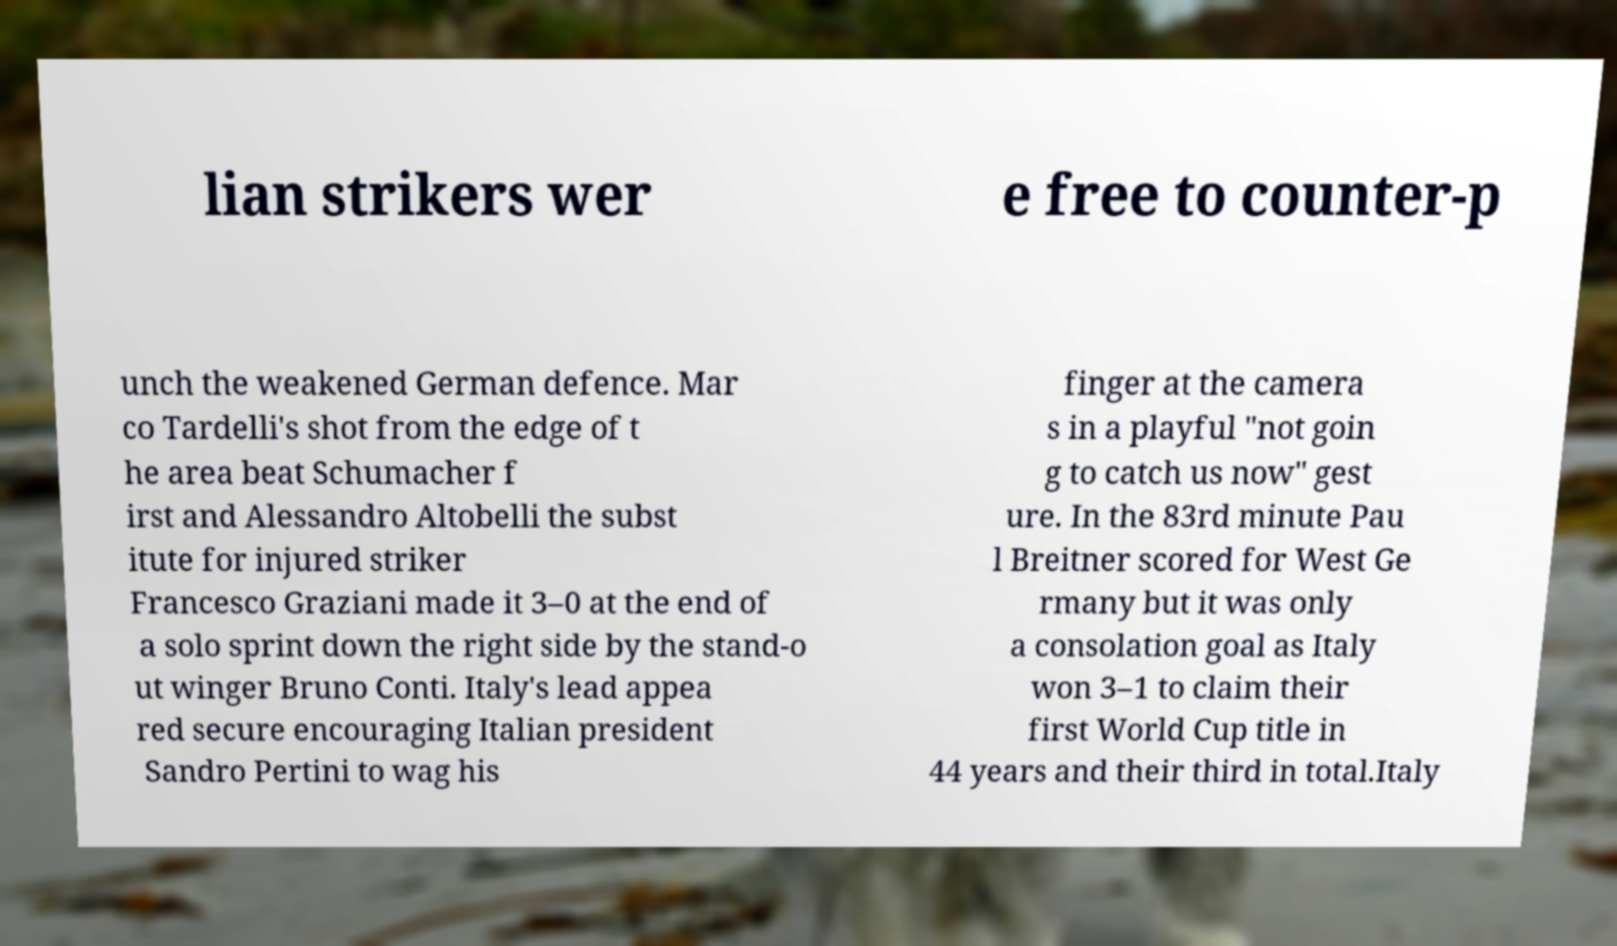Could you extract and type out the text from this image? lian strikers wer e free to counter-p unch the weakened German defence. Mar co Tardelli's shot from the edge of t he area beat Schumacher f irst and Alessandro Altobelli the subst itute for injured striker Francesco Graziani made it 3–0 at the end of a solo sprint down the right side by the stand-o ut winger Bruno Conti. Italy's lead appea red secure encouraging Italian president Sandro Pertini to wag his finger at the camera s in a playful "not goin g to catch us now" gest ure. In the 83rd minute Pau l Breitner scored for West Ge rmany but it was only a consolation goal as Italy won 3–1 to claim their first World Cup title in 44 years and their third in total.Italy 